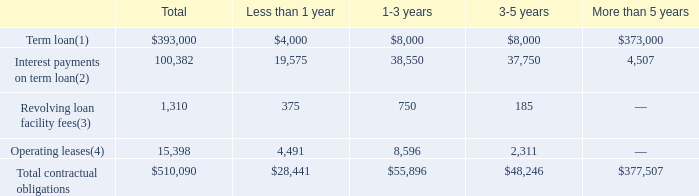ITEM 7. MANAGEMENT'S DISCUSSION AND ANALYSIS OF FINANCIAL CONDITION AND RESULTS OF OPERATIONS (United States Dollars in thousands, except per share data and unless otherwise indicated)
Contractual Obligations
Our principal commitments consisted of obligations under our outstanding term loan and operating leases for office facilities. The following table summarizes our commitments to settle contractual obligations in cash as of December 31, 2019.
(1) The principal balance of the term loan is repaid on a quarterly basis at an amortization rate of 0.25% per quarter, with the balance due at maturity
(2) Variable interest payments on our term loan are calculated based on the interest rate as of December 31, 2019 and the scheduled maturity of the underlying term loan.
(3) Amounts presented reflect a quarterly commitment fee rate of 0.375% per annum, and assume that the entire $100 million revolving loan facility is unused (the conditions that existed as of period end) for the duration of the agreement, which matures on March 29, 2023.
(4) Our operating leases are for office space. Certain of these leases contain provisions for rent escalations and/or lease concessions. Rental payments, as well as any step rent provisions specified in the lease agreements, are aggregated and charged evenly to expense over the lease term. However, amounts included herein do not reflect this accounting treatment, as they represent the future contractual lease cash obligations.
The payments that we may be required to make under the TRA to the TRA Parties may be significant and are not reflected in the contractual obligations table set forth above. Refer to Part I, Item 1A "Risk Factors–Risks Related to Our Organizational Structure" and to Note 13 to the Notes to Consolidated Financial Statements in Item 8 for additional detail.
The payments that we may be required to make under the TRA to the TRA Parties may be significant and are not reflected in the contractual obligations table set forth above. Refer to Part I, Item 1A "Risk Factors–Risks Related to Our Organizational Structure" and to Note 13 to the Notes to Consolidated Financial Statements in Item 8 for additional detail.
How was Interest payments on term loan calculated? Based on the interest rate as of december 31, 2019 and the scheduled maturity of the underlying term loan. What was the company's operating leases for? Office space. What were the total revolving loan facilities fees?
Answer scale should be: thousand. 1,310. How many contractual obligations had a total that exceeded $100,000 thousand? Term loan##Interest payments on term loan
Answer: 2. What was the difference in the total between Revolving loan facility fees and operating leases? 
Answer scale should be: thousand. 15,398-1,310
Answer: 14088. What was the contractual obligations due more than 5 years as a percentage of total contractual obligations?
Answer scale should be: percent. 377,507/510,090
Answer: 74.01. 